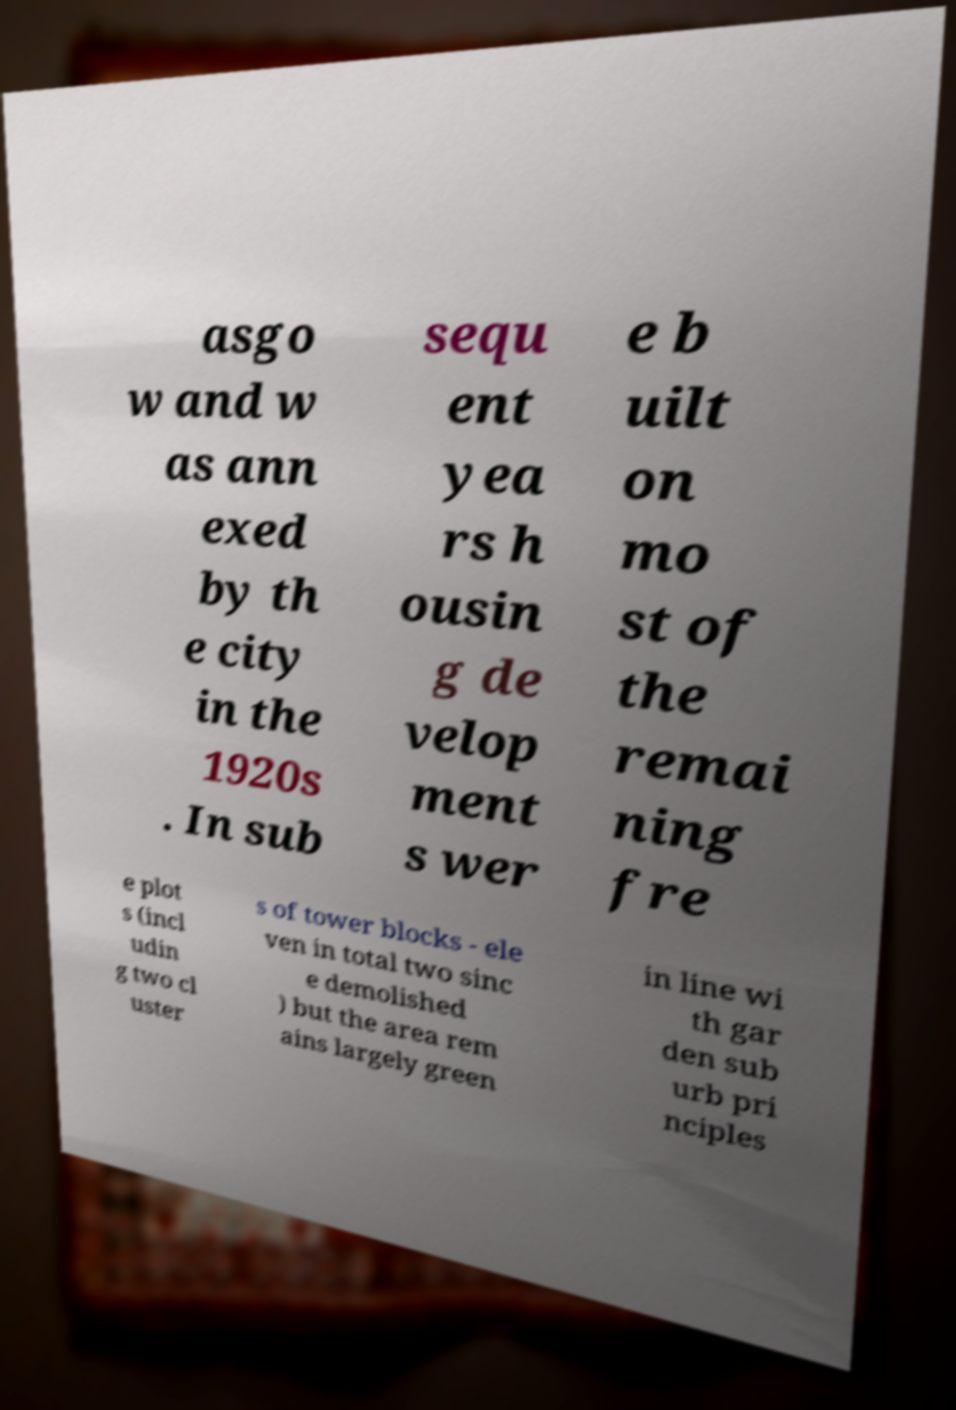Could you assist in decoding the text presented in this image and type it out clearly? asgo w and w as ann exed by th e city in the 1920s . In sub sequ ent yea rs h ousin g de velop ment s wer e b uilt on mo st of the remai ning fre e plot s (incl udin g two cl uster s of tower blocks - ele ven in total two sinc e demolished ) but the area rem ains largely green in line wi th gar den sub urb pri nciples 